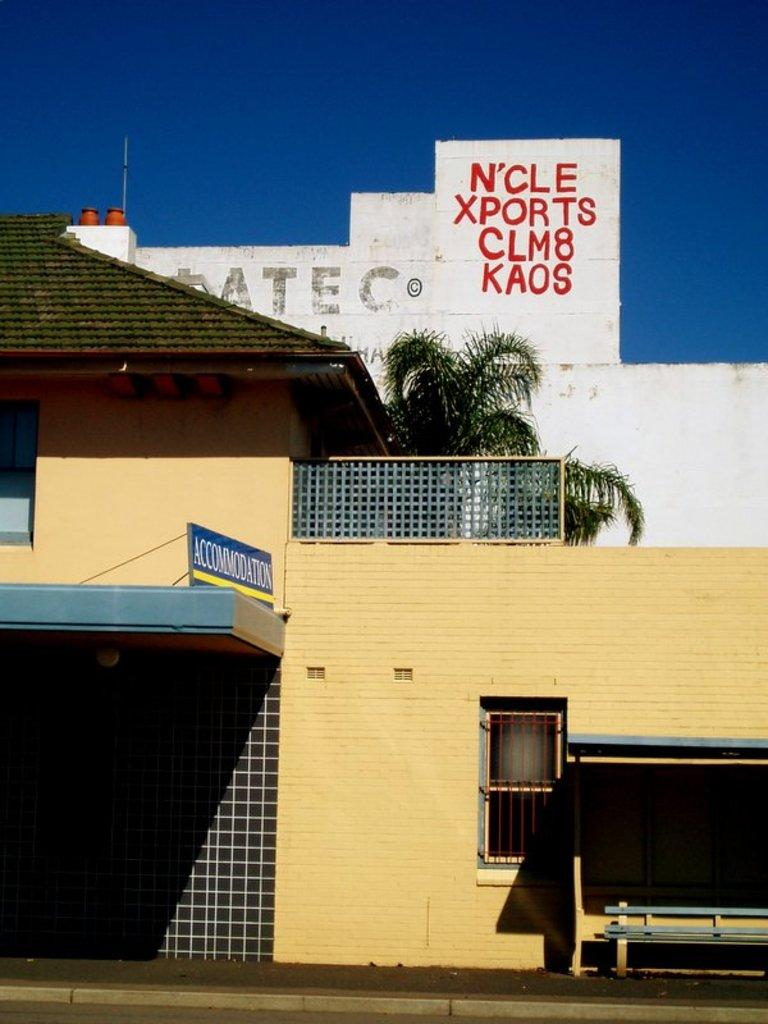What type of structures can be seen in the image? There are houses in the image. What type of vegetation is present in the image? There is a tree in the image. What is visible at the top of the image? The sky is visible at the top of the image, and it is clear. How is the ice distributed among the houses in the image? There is no ice present in the image, so it cannot be distributed among the houses. Can you describe the flock of birds flying over the tree in the image? There are no birds or flocks visible in the image; only houses, a tree, and the sky are present. 